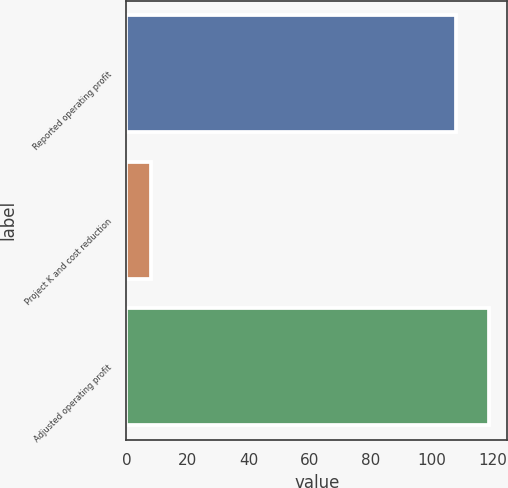Convert chart to OTSL. <chart><loc_0><loc_0><loc_500><loc_500><bar_chart><fcel>Reported operating profit<fcel>Project K and cost reduction<fcel>Adjusted operating profit<nl><fcel>108<fcel>8<fcel>118.8<nl></chart> 